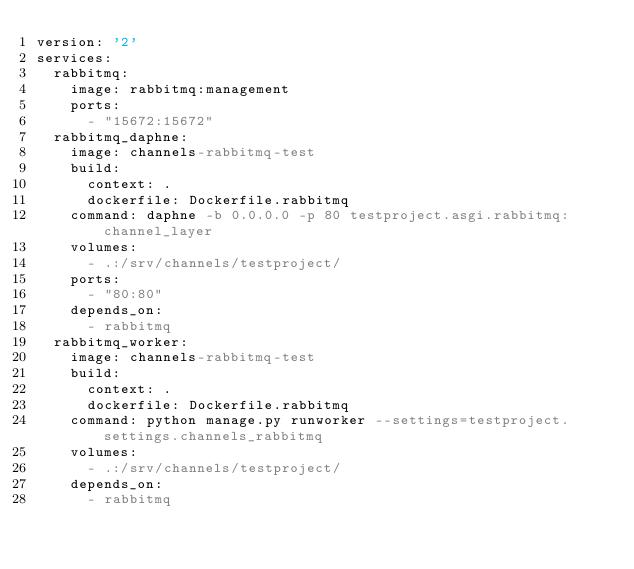<code> <loc_0><loc_0><loc_500><loc_500><_YAML_>version: '2'
services:
  rabbitmq:
    image: rabbitmq:management
    ports:
      - "15672:15672"
  rabbitmq_daphne:
    image: channels-rabbitmq-test
    build:
      context: .
      dockerfile: Dockerfile.rabbitmq
    command: daphne -b 0.0.0.0 -p 80 testproject.asgi.rabbitmq:channel_layer
    volumes:
      - .:/srv/channels/testproject/
    ports:
      - "80:80"
    depends_on:
      - rabbitmq
  rabbitmq_worker:
    image: channels-rabbitmq-test
    build:
      context: .
      dockerfile: Dockerfile.rabbitmq
    command: python manage.py runworker --settings=testproject.settings.channels_rabbitmq
    volumes:
      - .:/srv/channels/testproject/
    depends_on:
      - rabbitmq
</code> 